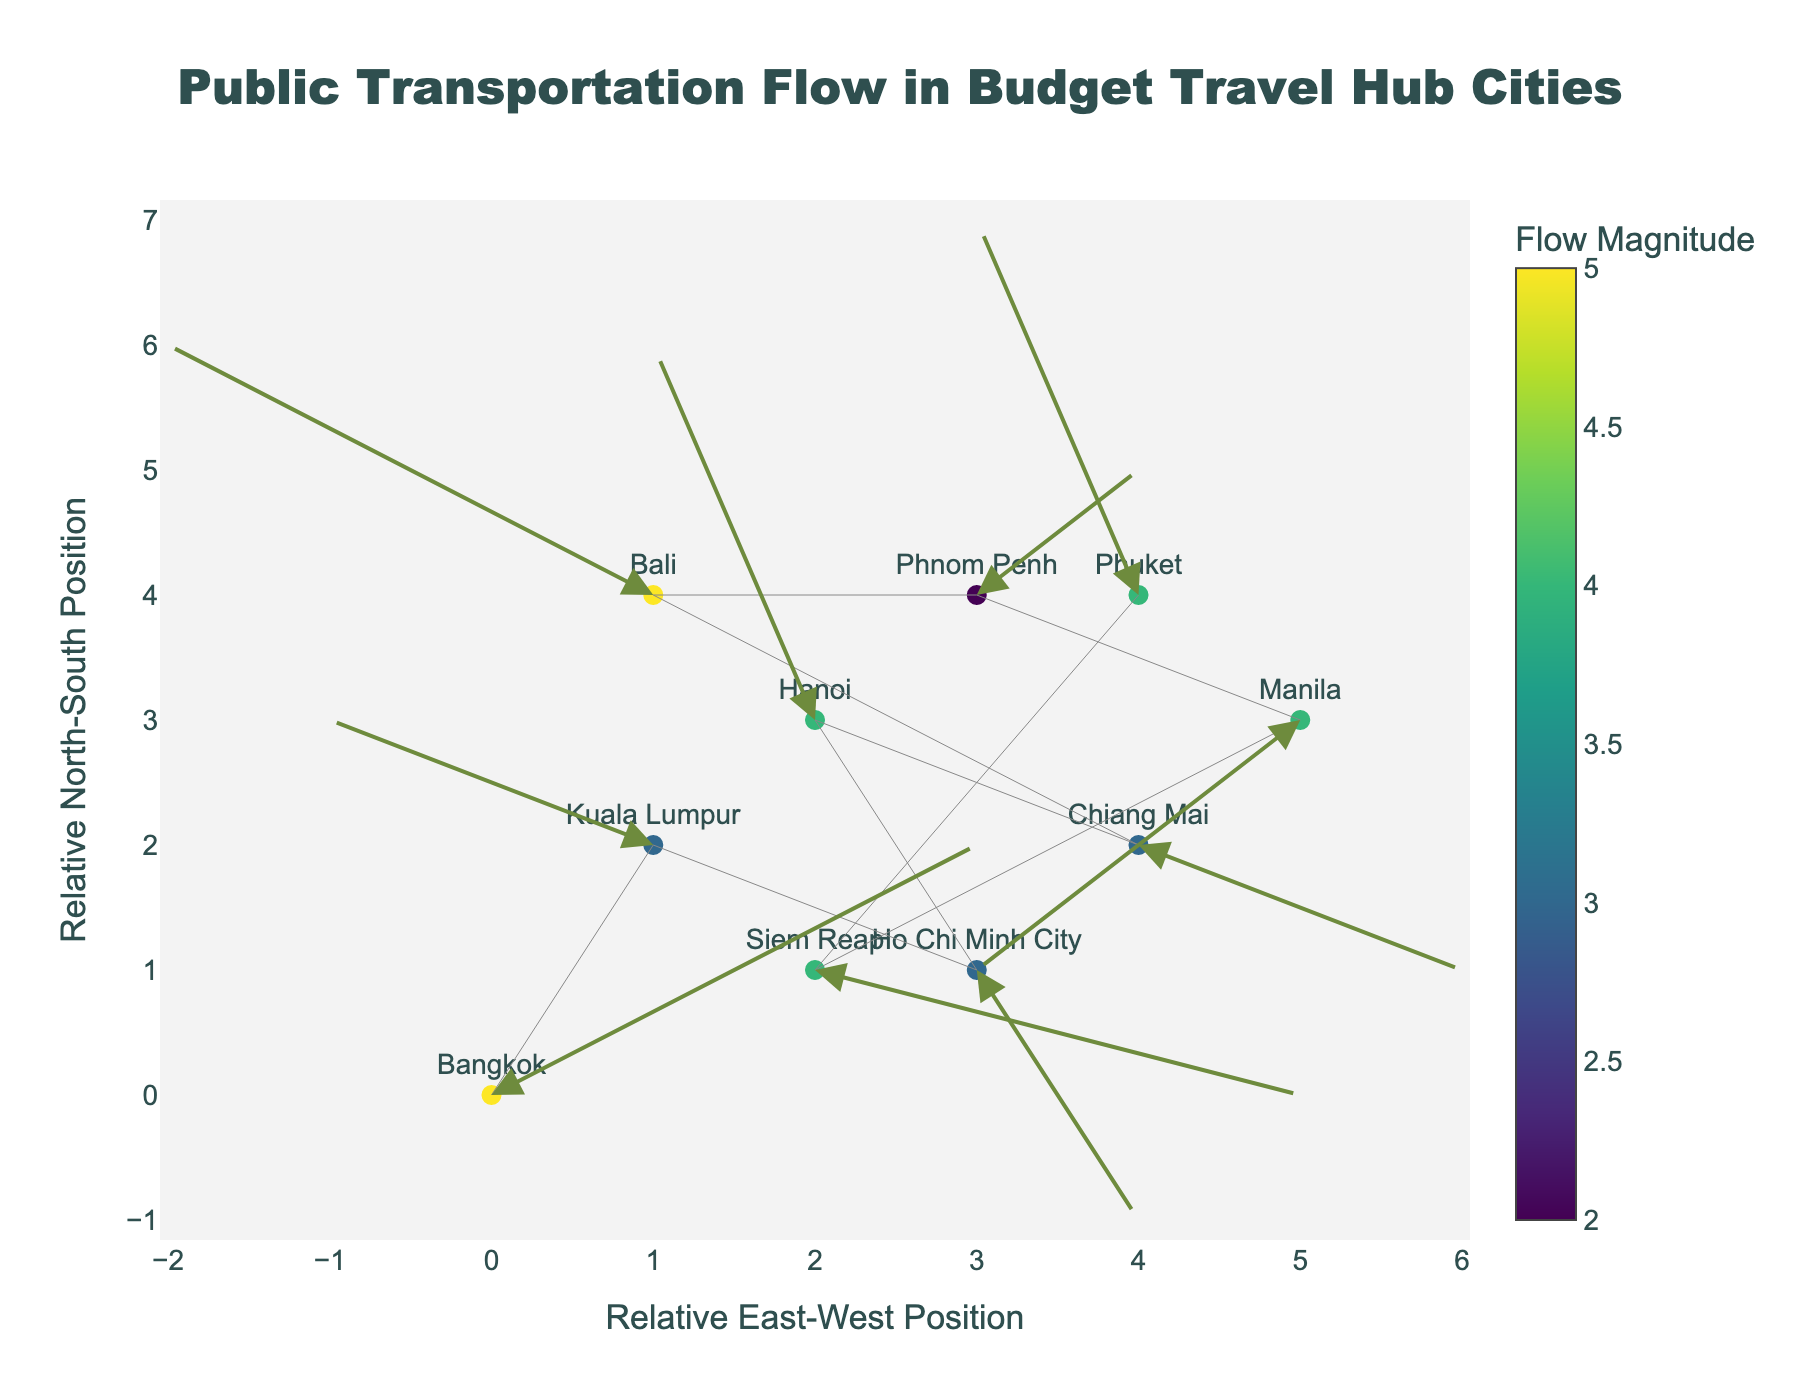What is the color used for the arrows in the plot? The figure uses a consistent arrow color for all flow arrows. Based on the plot details described, the arrows are colored in a shade of green.
Answer: green Which city has the highest public transportation flow magnitude? Magnitude of flow for each city is represented by the color bar. The city with the highest flow magnitude is the one with the most intense color. From the dataset, Bali has flow components (-3, 2), leading to a magnitude sqrt((-3)^2 + 2^2) = sqrt(13), which is the highest in the figure.
Answer: Bali How many cities are represented in the plot? By counting the number of text labels (i.e., city names) in the plot, we can determine the number of cities shown. Each data point represents a unique city. According to the dataset, there are 10 cities in total.
Answer: 10 Which cities show negative east-west movement? Negative east-west movement corresponds to the 'u' component being negative. From the data: Kuala Lumpur (u = -2), Hanoi (u = -1), Bali (u = -3), Phnom Penh (u = -1), and Manila (u = -2) exhibit this movement.
Answer: Kuala Lumpur, Hanoi, Bali, Phnom Penh, Manila What are the positions of Siem Reap and Phuket, and how do their movements compare? The coordinates and movements from the dataset: Siem Reap (2,1) moves (3,-1) and Phuket (4,4) moves (-1,3). Siem Reap's movement has a net eastward and slight southward direction, while Phuket's movement is westward and northward. The directions are opposite in the east-west component, but similar in the north-south component.
Answer: Siem Reap: (2,1) moves (3, -1); Phuket: (4,4) moves (-1, 3) What is the title of the plot? The plot's title is derived from the layout description and represents the theme of the plot. The title of the plot is "Public Transportation Flow in Budget Travel Hub Cities".
Answer: Public Transportation Flow in Budget Travel Hub Cities Which city has the least north-south movement and what is its magnitude? North-south movement corresponds to the 'v' component. The city with the least north-south movement has a 'v' closest to 0. Based on the dataset, Siem Reap has the least north-south movement with 'v' = -1.
Answer: Siem Reap (1) How many cities exhibit a net eastward movement? Net eastward movement corresponds to positive 'u' values. According to the dataset, Bangkok (u=3), Ho Chi Minh City (u=1), Chiang Mai (u=2), Siem Reap (u=3), and Phnom Penh (u=1) exhibit this movement. There are 5 cities in total.
Answer: 5 